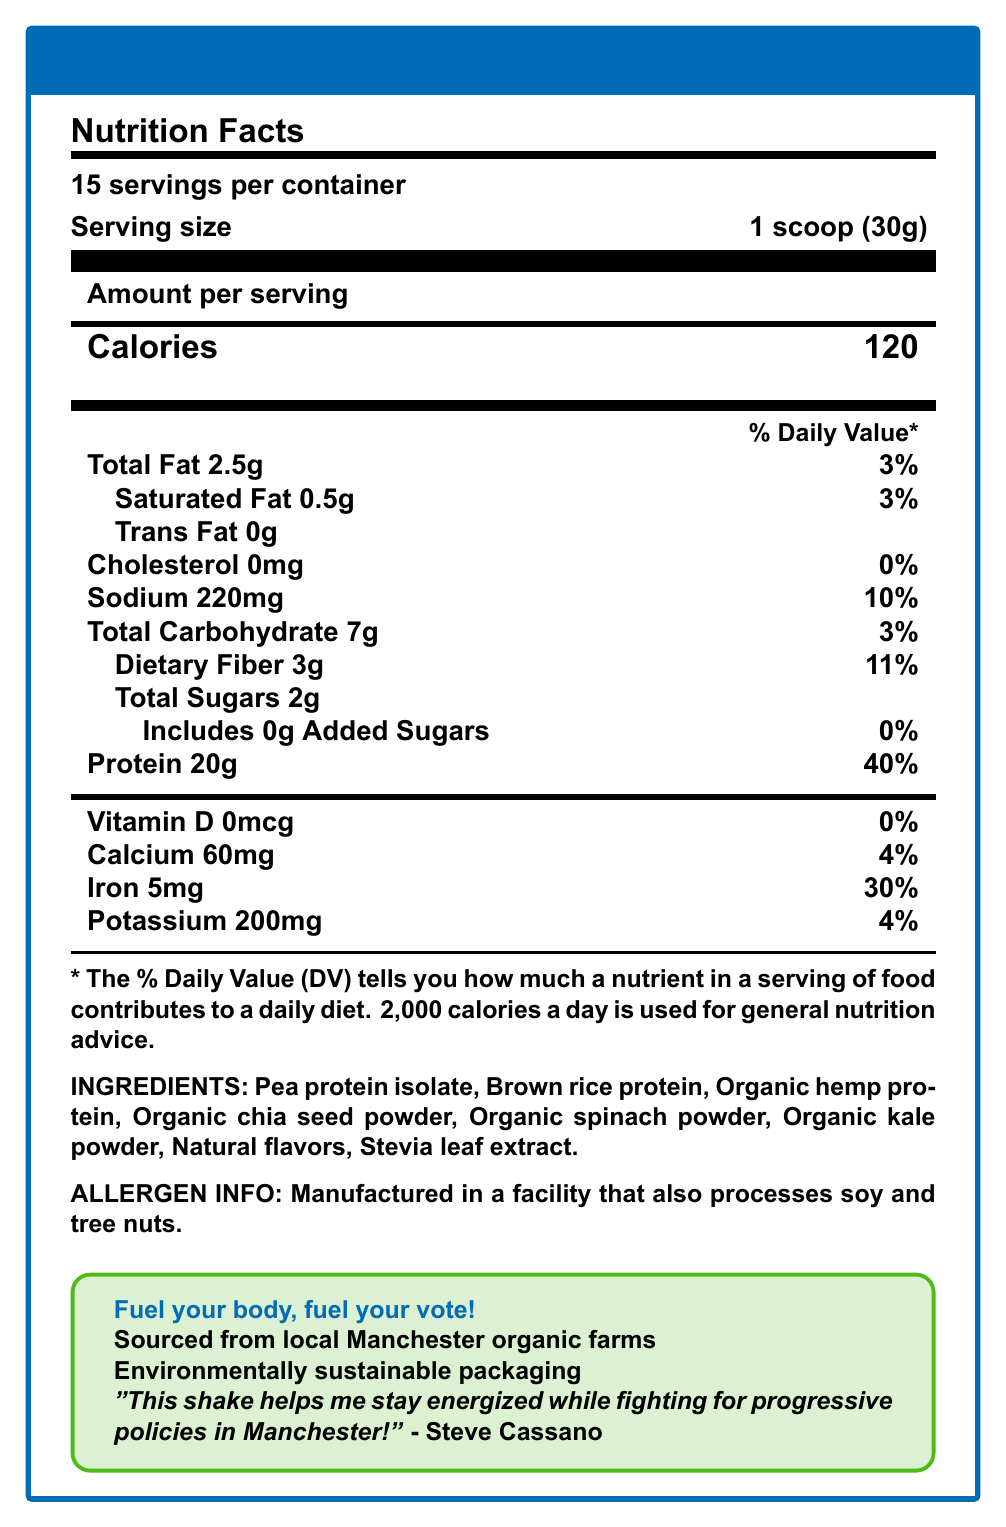What is the serving size for Steve's Green Power Shake? The serving size is listed as "1 scoop (30g)" under the Nutrition Facts section.
Answer: 1 scoop (30g) How many servings are there per container? The document states "15 servings per container."
Answer: 15 What percentage of the daily value of protein does one serving of Steve's Green Power Shake provide? The protein section shows that 20g of protein constitutes 40% of the daily value.
Answer: 40% What is the total amount of iron in one serving? The Nutrition Facts list 5mg of iron per serving.
Answer: 5mg List three main ingredients in Steve's Green Power Shake. These ingredients are among the first listed in the ingredients section.
Answer: Pea protein isolate, Brown rice protein, Organic hemp protein Which of the following is NOT an ingredient in the shake? A. Brown rice protein B. Organic kale powder C. Sugar D. Stevia leaf extract Sugar is not listed in the ingredients; instead, there are Organic kale powder, Brown rice protein, and Stevia leaf extract.
Answer: C What is the percentage of the daily value for dietary fiber? A. 3% B. 5% C. 11% D. 15% The document lists dietary fiber as 11% of the daily value per serving.
Answer: C Does Steve's Green Power Shake contain cholesterol? The document states that the amount of cholesterol is 0mg, contributing 0% of the daily value.
Answer: No Summarize the main message of the document. The document details nutritional information, ingredients, allergen info, and emphasizes the local and sustainable sourcing and its endorsement by Steve Cassano.
Answer: The document provides the nutrition facts for "Steve's Green Power Shake," a plant-based protein shake endorsed by Steve Cassano, emphasizing its nutritional benefits and health-conscious ingredients. Sourced from local Manchester farms, this product aligns with Democratic values such as sustainability and progressive health policies. What is the potassium content in one serving? The document states that one serving contains 200mg of potassium.
Answer: 200mg Does the shake contain any added sugars? The document specifies that the shake includes 0g of added sugars, contributing 0% of the daily value.
Answer: No Where is the main protein source derived from in Steve's Green Power Shake? The document lists multiple protein sources such as Pea protein isolate, Brown rice protein, and Organic hemp protein, but does not specify which is the main source.
Answer: Not enough information What is the campaign slogan associated with Steve's Green Power Shake? The campaign slogan is listed in a highlighted section of the document.
Answer: Fuel your body, fuel your vote! How much sodium is there in one serving? The Nutrition Facts indicate that there are 220mg of sodium per serving.
Answer: 220mg Is the shake environmentally sustainable in its packaging? The document mentions "Environmentally sustainable packaging" under Democratic values.
Answer: Yes 